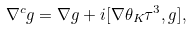Convert formula to latex. <formula><loc_0><loc_0><loc_500><loc_500>\nabla ^ { c } { g } = \nabla { g } + i [ \nabla \theta _ { K } \tau ^ { 3 } , { g } ] ,</formula> 